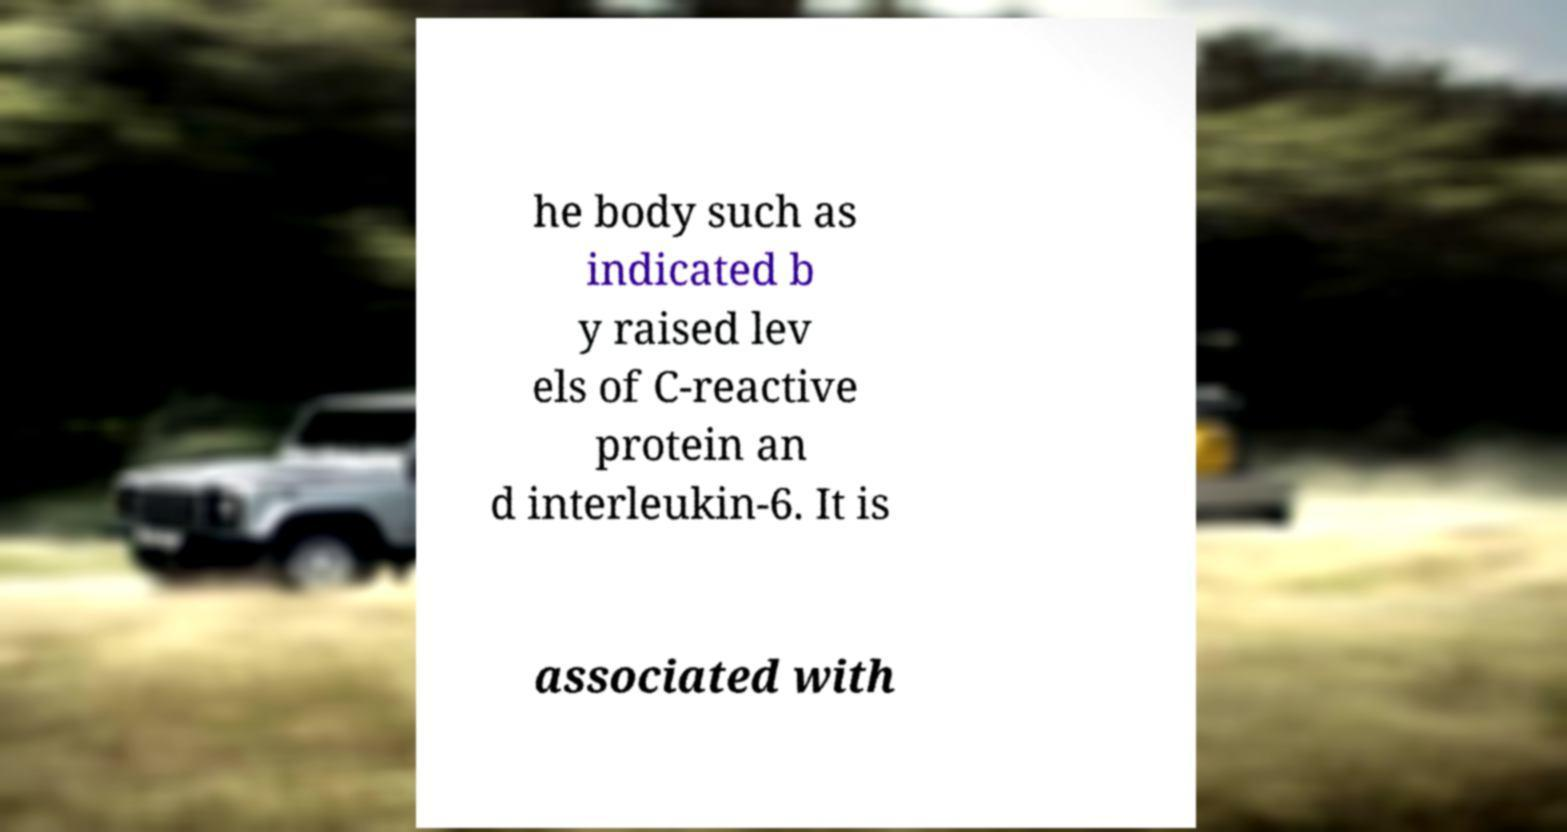Can you read and provide the text displayed in the image?This photo seems to have some interesting text. Can you extract and type it out for me? he body such as indicated b y raised lev els of C-reactive protein an d interleukin-6. It is associated with 